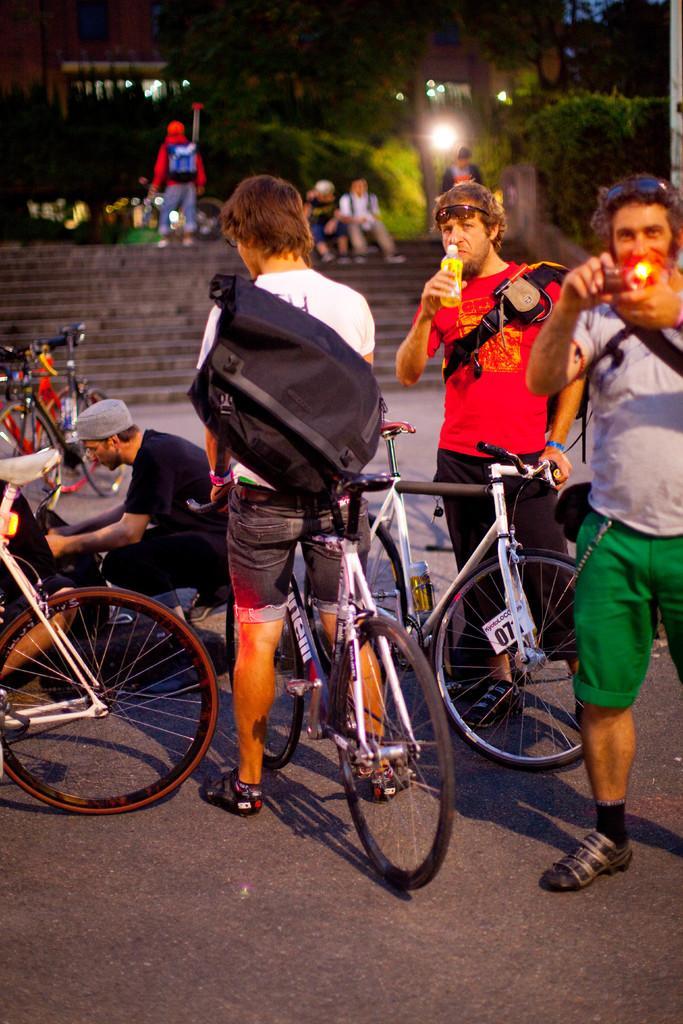Describe this image in one or two sentences. There are group of people standing and one man holding bicycle. 